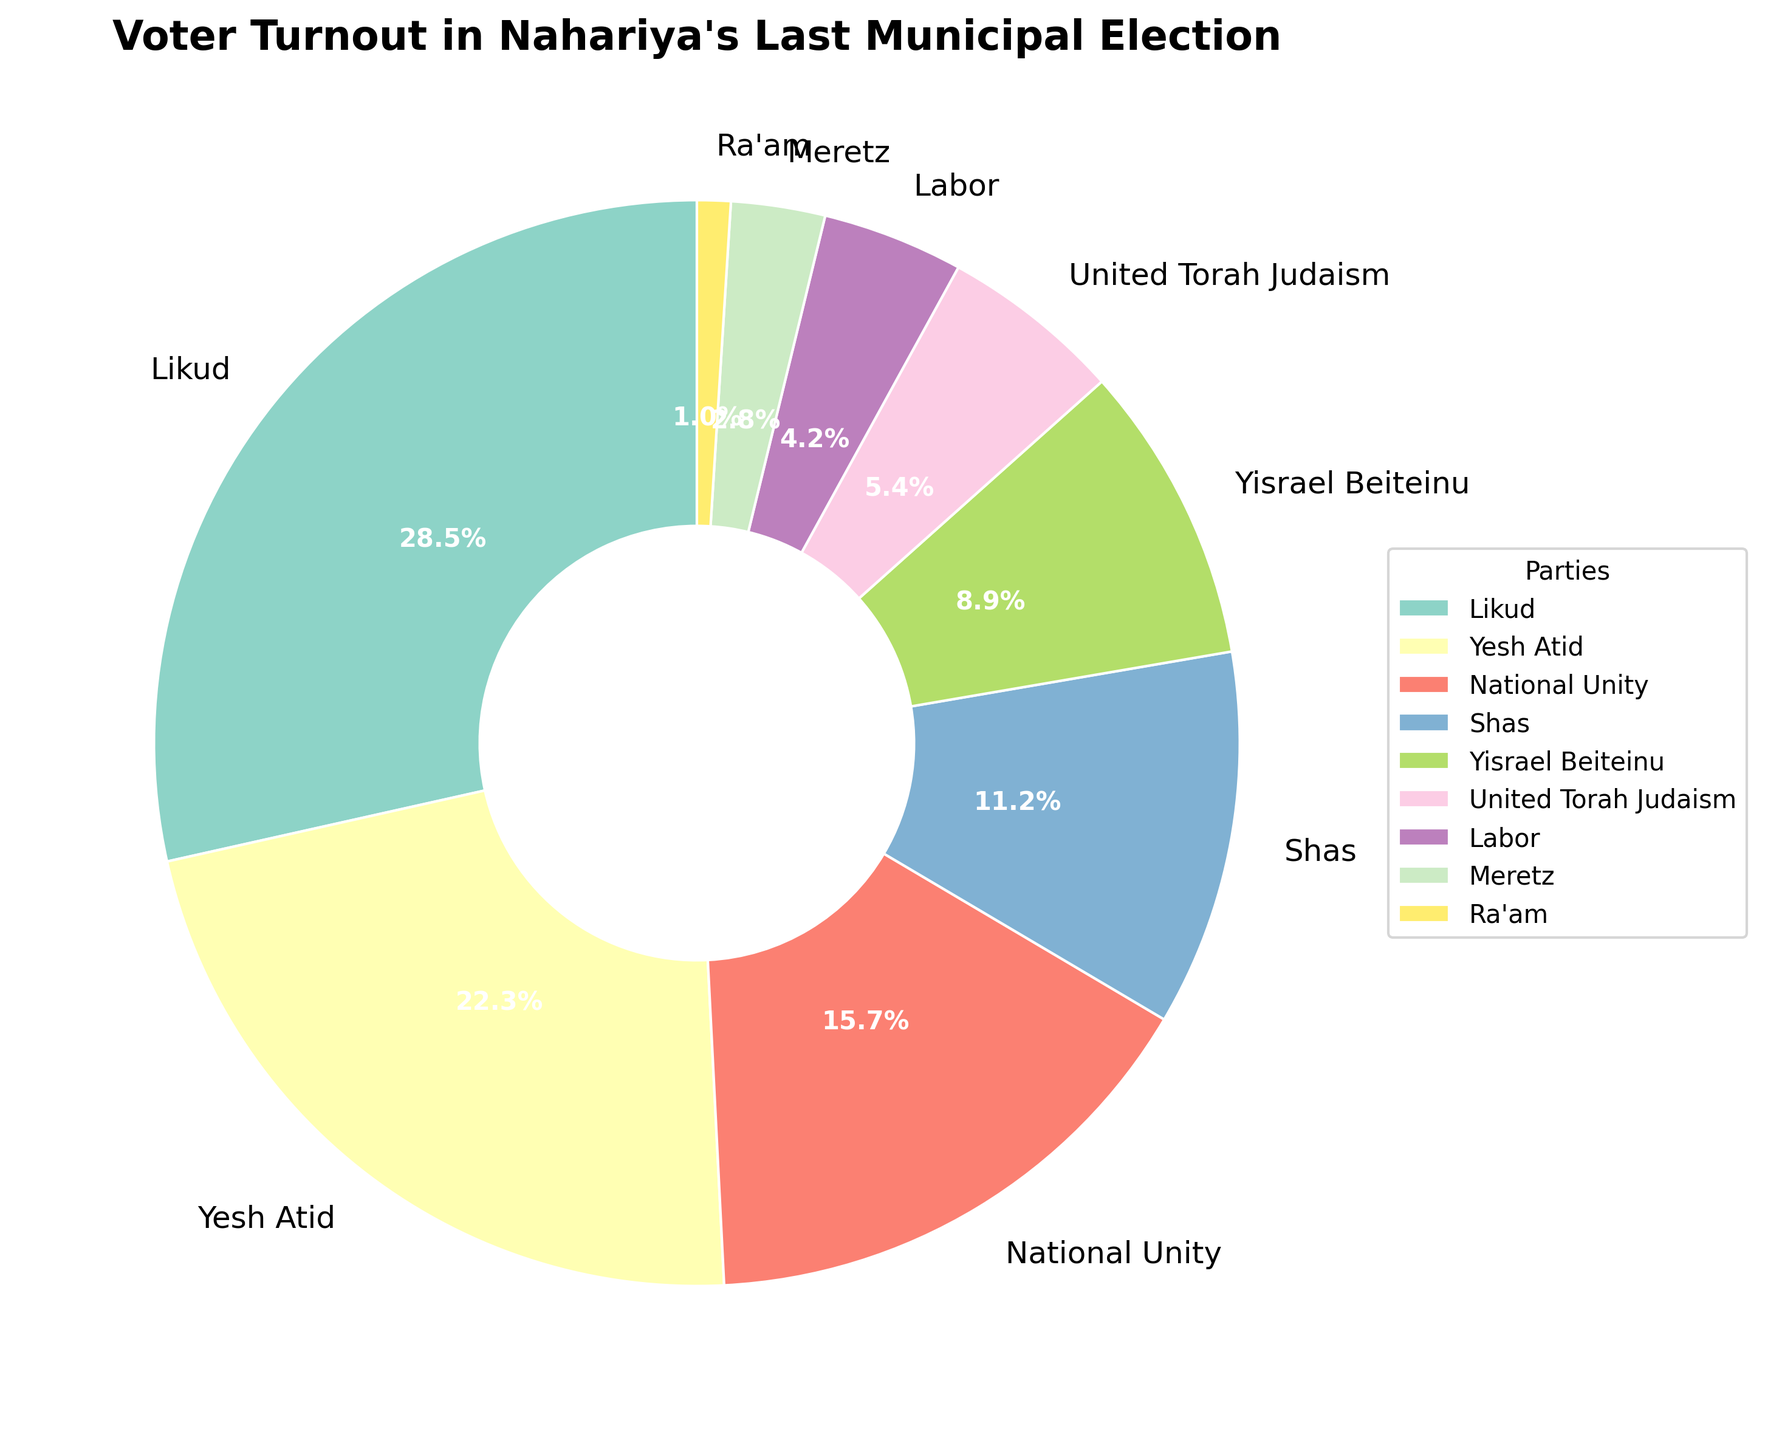What's the percentage of votes for Shas and Yisrael Beiteinu combined? The percentage of votes for Shas is 11.2% and for Yisrael Beiteinu is 8.9%. Adding these two percentages gives 11.2 + 8.9 = 20.1%.
Answer: 20.1% Which party received the smallest share of votes? Observing the percentages on the chart, Ra'am has the smallest share of votes with 1.0%.
Answer: Ra'am How does the vote percentage for Likud compare to Yesh Atid? Likud received 28.5% of the votes, while Yesh Atid received 22.3%. Comparing these, Likud received 6.2 percentage points more than Yesh Atid.
Answer: Likud received 6.2% more Is Meretz's share larger than Ra'am's? Meretz's share is 2.8%, while Ra'am's is 1.0%. Since 2.8 is greater than 1.0, Meretz's share is larger.
Answer: Yes What is the total percentage of votes received by Likud, Yesh Atid, and National Unity? Summing the percentages: Likud has 28.5%, Yesh Atid 22.3%, and National Unity 15.7%. Adding these: 28.5 + 22.3 + 15.7 = 66.5%.
Answer: 66.5% Which party's slice is right next to Yisrael Beiteinu in the clockwise direction? On the chart, moving clockwise from Yisrael Beiteinu (8.9%), the next slice belongs to United Torah Judaism (5.4%).
Answer: United Torah Judaism What's the average percentage of the bottom three parties by vote share? The bottom three parties by vote share are Meretz (2.8%), United Torah Judaism (5.4%), and Ra'am (1.0%). Calculating the average: (2.8 + 5.4 + 1.0) / 3 = 3.07%.
Answer: 3.07% How do the percentages for National Unity and Shas compare? National Unity has 15.7% and Shas has 11.2%. National Unity received 4.5 percentage points more than Shas.
Answer: National Unity received 4.5% more Which party has a greater share: Labor or Meretz? Labor has 4.2%, while Meretz has 2.8%. Since 4.2 is greater than 2.8, Labor has a greater share.
Answer: Labor What's the visual element used to identify different parties in the pie chart? Different colors are used to distinguish each party in the pie chart.
Answer: Colors 